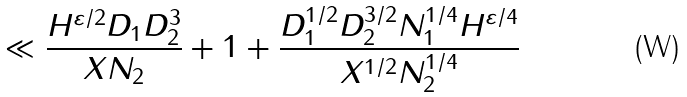Convert formula to latex. <formula><loc_0><loc_0><loc_500><loc_500>& \ll \frac { H ^ { \varepsilon / 2 } D _ { 1 } D _ { 2 } ^ { 3 } } { X N _ { 2 } } + 1 + \frac { D _ { 1 } ^ { 1 / 2 } D _ { 2 } ^ { 3 / 2 } N _ { 1 } ^ { 1 / 4 } H ^ { \varepsilon / 4 } } { X ^ { 1 / 2 } N _ { 2 } ^ { 1 / 4 } }</formula> 